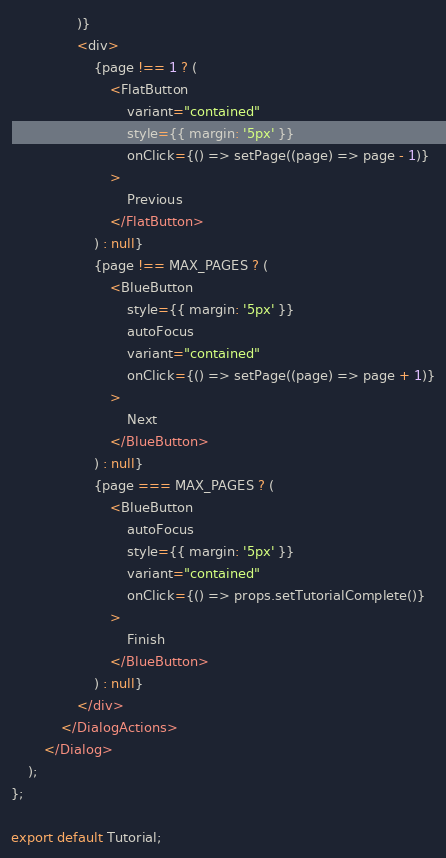Convert code to text. <code><loc_0><loc_0><loc_500><loc_500><_TypeScript_>                )}
                <div>
                    {page !== 1 ? (
                        <FlatButton
                            variant="contained"
                            style={{ margin: '5px' }}
                            onClick={() => setPage((page) => page - 1)}
                        >
                            Previous
                        </FlatButton>
                    ) : null}
                    {page !== MAX_PAGES ? (
                        <BlueButton
                            style={{ margin: '5px' }}
                            autoFocus
                            variant="contained"
                            onClick={() => setPage((page) => page + 1)}
                        >
                            Next
                        </BlueButton>
                    ) : null}
                    {page === MAX_PAGES ? (
                        <BlueButton
                            autoFocus
                            style={{ margin: '5px' }}
                            variant="contained"
                            onClick={() => props.setTutorialComplete()}
                        >
                            Finish
                        </BlueButton>
                    ) : null}
                </div>
            </DialogActions>
        </Dialog>
    );
};

export default Tutorial;
</code> 